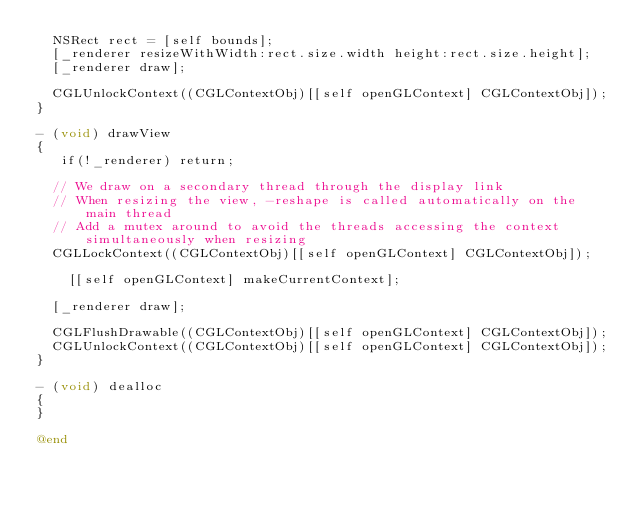Convert code to text. <code><loc_0><loc_0><loc_500><loc_500><_ObjectiveC_>	NSRect rect = [self bounds];
	[_renderer resizeWithWidth:rect.size.width height:rect.size.height];
	[_renderer draw];
	
	CGLUnlockContext((CGLContextObj)[[self openGLContext] CGLContextObj]);
}

- (void) drawView
{
   if(!_renderer) return;
   
	// We draw on a secondary thread through the display link
	// When resizing the view, -reshape is called automatically on the main thread
	// Add a mutex around to avoid the threads accessing the context simultaneously	when resizing
	CGLLockContext((CGLContextObj)[[self openGLContext] CGLContextObj]);
    
    [[self openGLContext] makeCurrentContext];
	
	[_renderer draw];
	
	CGLFlushDrawable((CGLContextObj)[[self openGLContext] CGLContextObj]);
	CGLUnlockContext((CGLContextObj)[[self openGLContext] CGLContextObj]);
}

- (void) dealloc
{
}

@end
</code> 